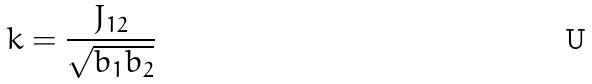<formula> <loc_0><loc_0><loc_500><loc_500>k = \frac { J _ { 1 2 } } { \sqrt { b _ { 1 } b _ { 2 } } }</formula> 